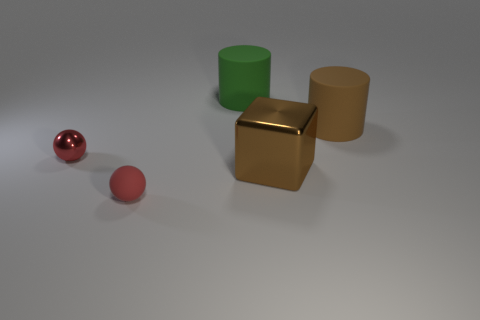There is a sphere that is the same color as the tiny metal thing; what size is it?
Ensure brevity in your answer.  Small. How many other objects are the same size as the brown matte object?
Your response must be concise. 2. There is a matte thing that is both in front of the green cylinder and to the left of the big brown metal cube; how big is it?
Your answer should be compact. Small. What number of small red rubber things have the same shape as the tiny red metallic object?
Keep it short and to the point. 1. What is the material of the block?
Offer a very short reply. Metal. Is the small red matte thing the same shape as the small shiny object?
Your answer should be very brief. Yes. Are there any tiny objects that have the same material as the brown cube?
Offer a terse response. Yes. There is a matte object that is in front of the large green cylinder and left of the brown shiny cube; what is its color?
Your answer should be very brief. Red. There is a brown thing in front of the tiny red shiny object; what is its material?
Offer a terse response. Metal. Is there another thing that has the same shape as the red matte thing?
Make the answer very short. Yes. 